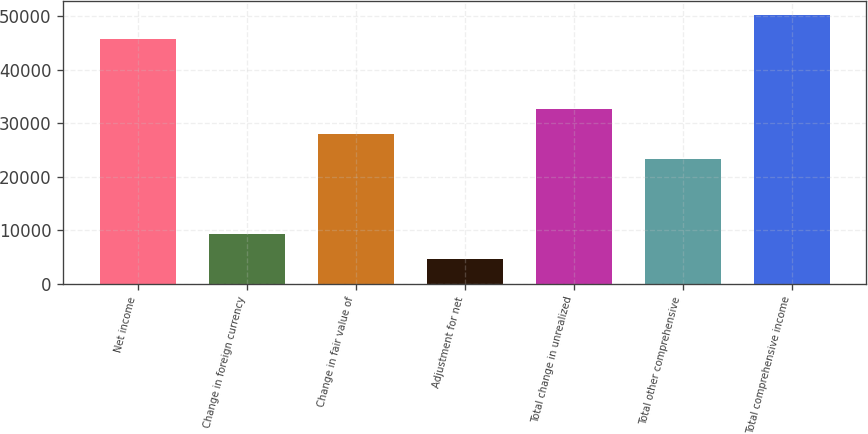Convert chart to OTSL. <chart><loc_0><loc_0><loc_500><loc_500><bar_chart><fcel>Net income<fcel>Change in foreign currency<fcel>Change in fair value of<fcel>Adjustment for net<fcel>Total change in unrealized<fcel>Total other comprehensive<fcel>Total comprehensive income<nl><fcel>45687<fcel>9338.8<fcel>28002.4<fcel>4672.9<fcel>32668.3<fcel>23336.5<fcel>50352.9<nl></chart> 